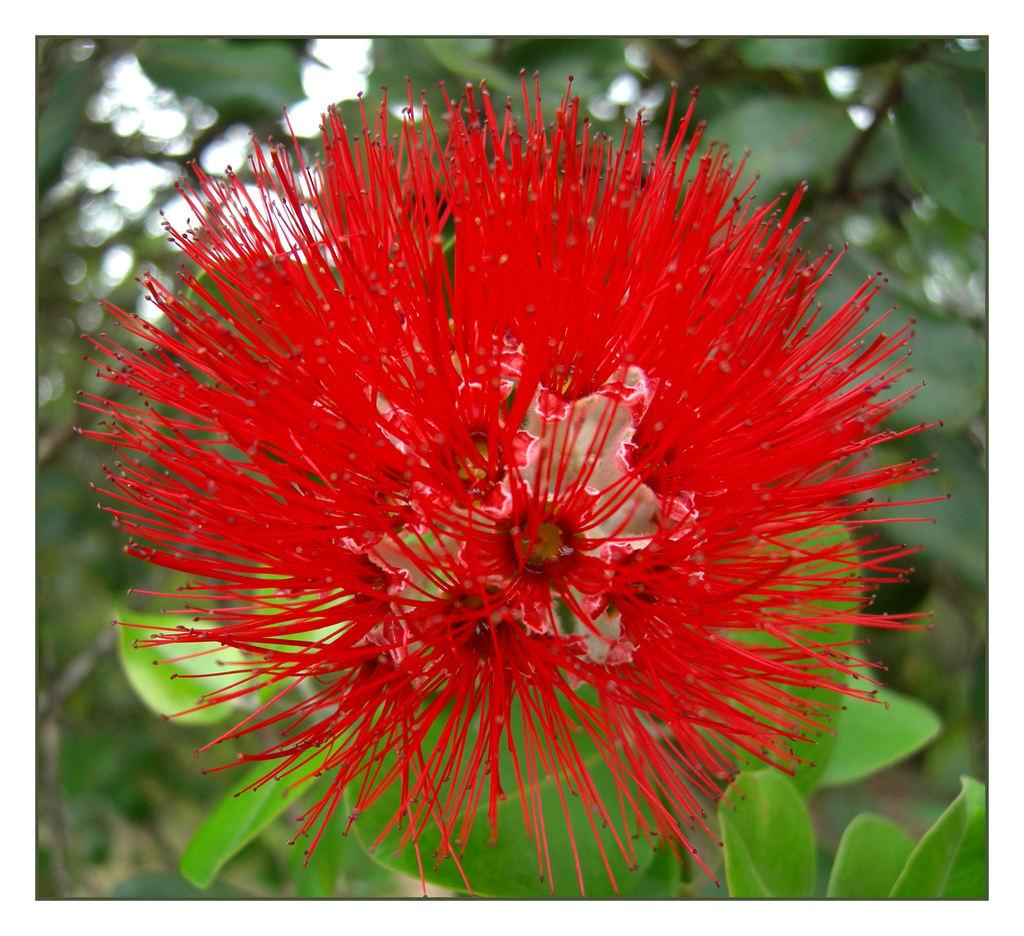What type of plant can be seen in the image? There is a red flower in the image. What else is visible in the background of the image? There is a group of leaves in the background of the image. What is the opinion of the airport on the red flower in the image? There is no airport present in the image, and therefore it cannot have an opinion on the red flower. 